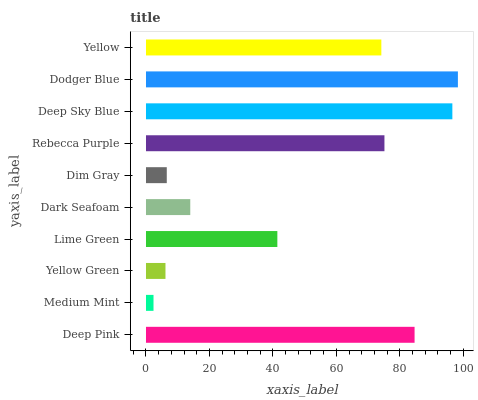Is Medium Mint the minimum?
Answer yes or no. Yes. Is Dodger Blue the maximum?
Answer yes or no. Yes. Is Yellow Green the minimum?
Answer yes or no. No. Is Yellow Green the maximum?
Answer yes or no. No. Is Yellow Green greater than Medium Mint?
Answer yes or no. Yes. Is Medium Mint less than Yellow Green?
Answer yes or no. Yes. Is Medium Mint greater than Yellow Green?
Answer yes or no. No. Is Yellow Green less than Medium Mint?
Answer yes or no. No. Is Yellow the high median?
Answer yes or no. Yes. Is Lime Green the low median?
Answer yes or no. Yes. Is Dim Gray the high median?
Answer yes or no. No. Is Dark Seafoam the low median?
Answer yes or no. No. 